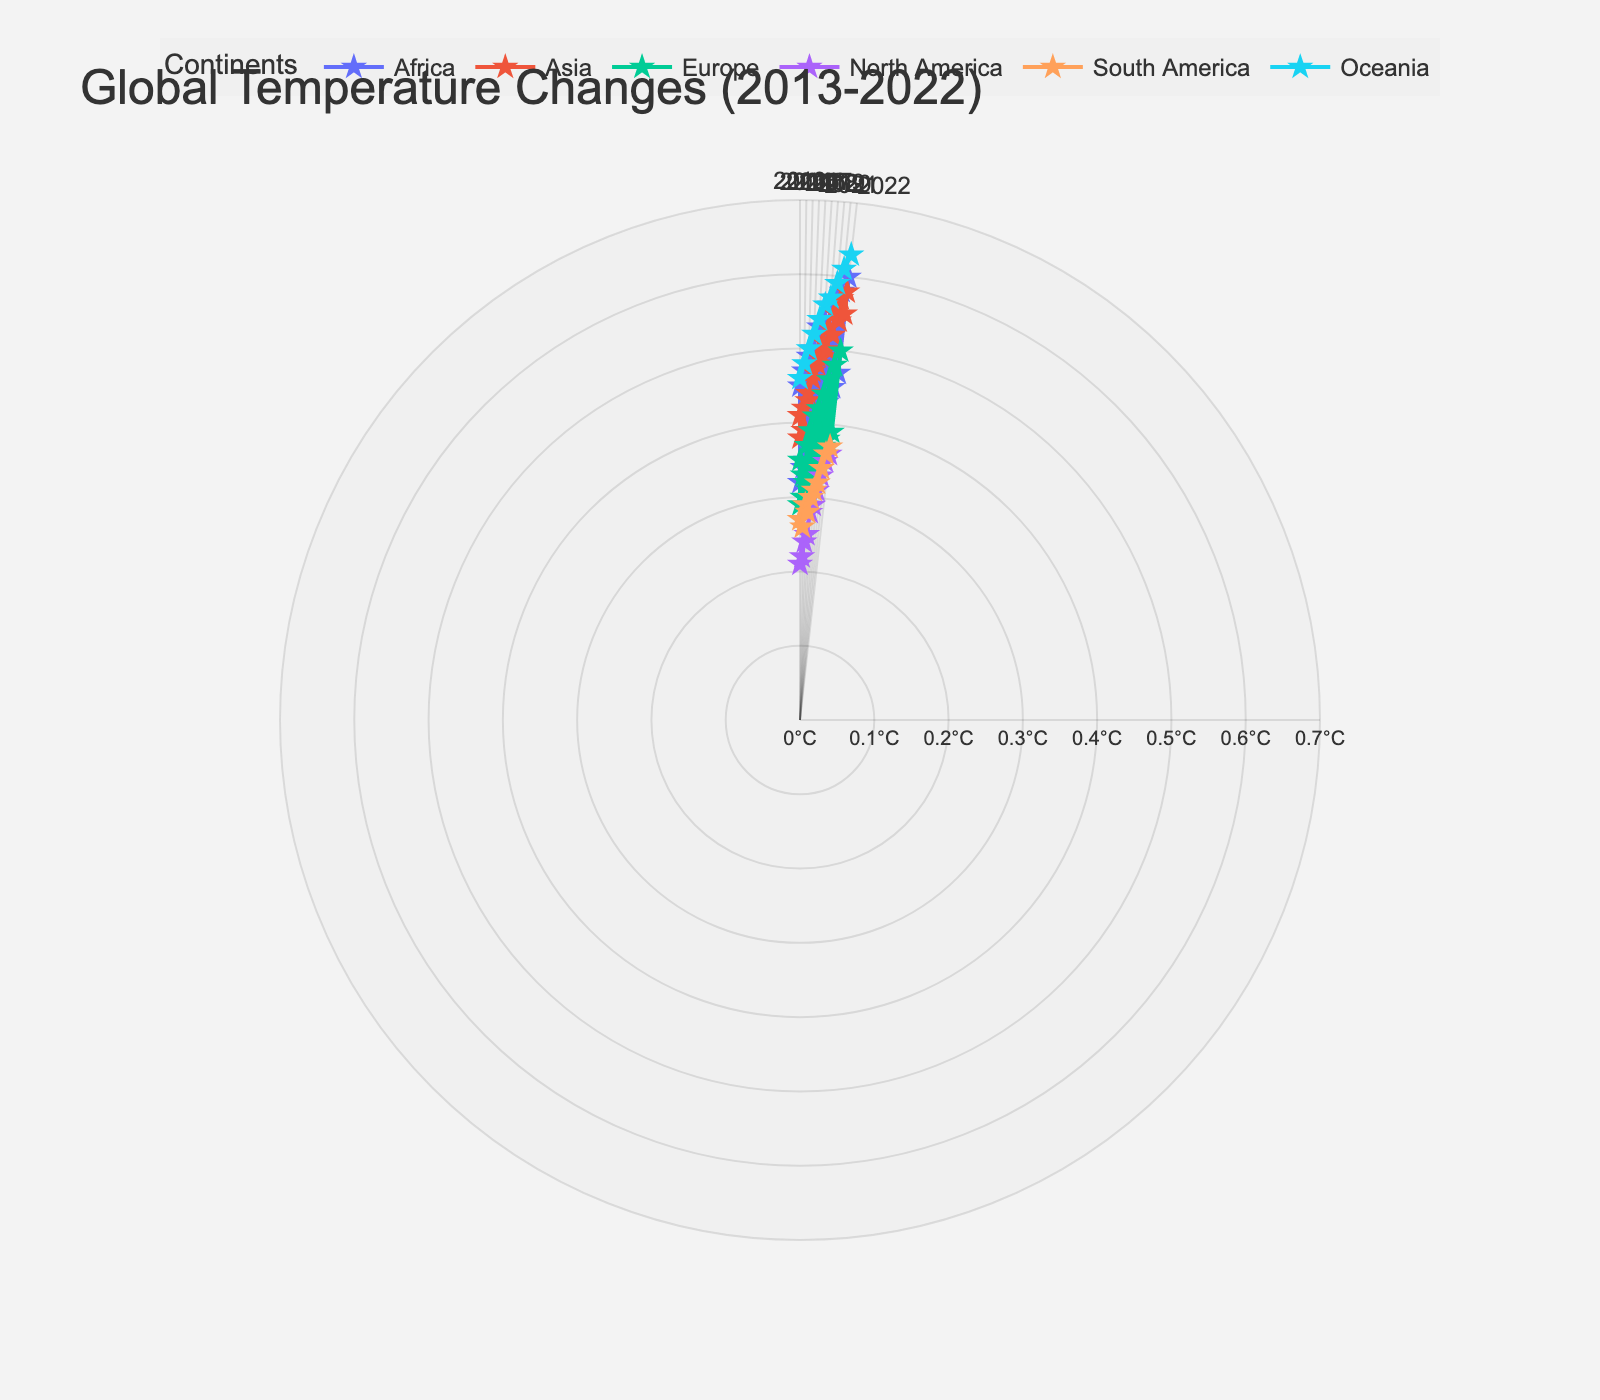What's the title of the figure? The title is displayed prominently at the top of the chart. It reads "Global Temperature Changes (2013-2022)".
Answer: Global Temperature Changes (2013-2022) How many continents are represented in the plot? By looking at the legend, you can count the different continent names listed, which are Africa, Asia, Europe, North America, South America, and Oceania.
Answer: 6 Which continent shows the highest average temperature change in 2022? By identifying the markers in the outermost ring for 2022, we see that "Oceania" (notably Australia) has the highest radial value, indicating the highest average temperature change.
Answer: Oceania What is the average temperature change of Kenya in 2016? Hovering over or looking up the point for "Kenya" under Africa in 2016, the figure shows 0.37°C.
Answer: 0.37°C Which country in Europe had a higher temperature change in 2021, Germany or France? Finding the points in 2021 for Europe, and comparing Germany and France, France has a higher average temperature change.
Answer: France What was the average temperature change in the United States in 2020? By locating the United States data point for the year 2020, the recorded value is visible as 0.33°C.
Answer: 0.33°C Compare the changes in average temperature for China and India in 2017: which was higher? For 2017 under Asia, observe both points and compare their radial values. China's value is slightly higher than India's.
Answer: China Which continent shows the least variation in temperature change across the decade? By looking at the radial values variation (from inner to outer), Europe shows the smallest range, indicating the least temperature change variation.
Answer: Europe What is the general trend observed in the average temperature changes from 2013 to 2022? Tracking the average placement of data points over the years, most continents show an increasing radial trend, indicating rising average temperature changes.
Answer: Increasing trend How does Australia's average temperature change in 2015 compare to that in 2018? Locate Australia's data points for 2015 and 2018, comparing their radial distances. 2018 shows a higher average temperature change than 2015.
Answer: 2018 is higher 